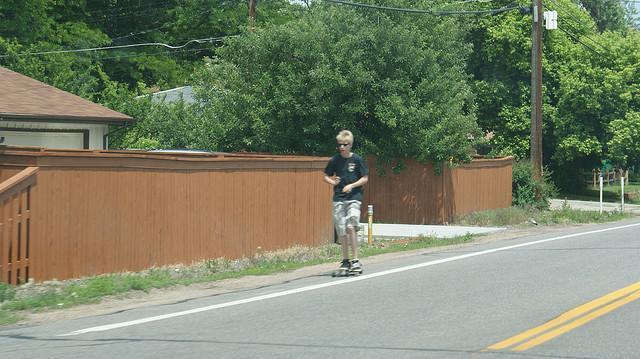How many chairs at the table?
Give a very brief answer. 0. 